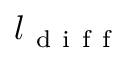<formula> <loc_0><loc_0><loc_500><loc_500>l _ { d i f f }</formula> 